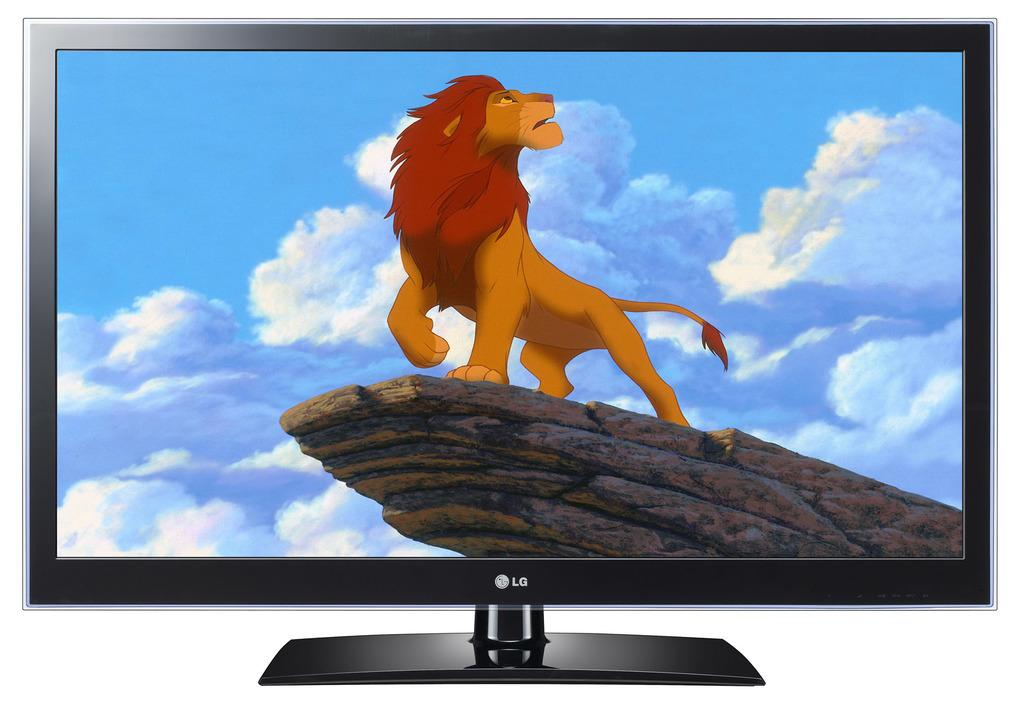<image>
Provide a brief description of the given image. A black flat panel television with a cartoon lion on screen. 